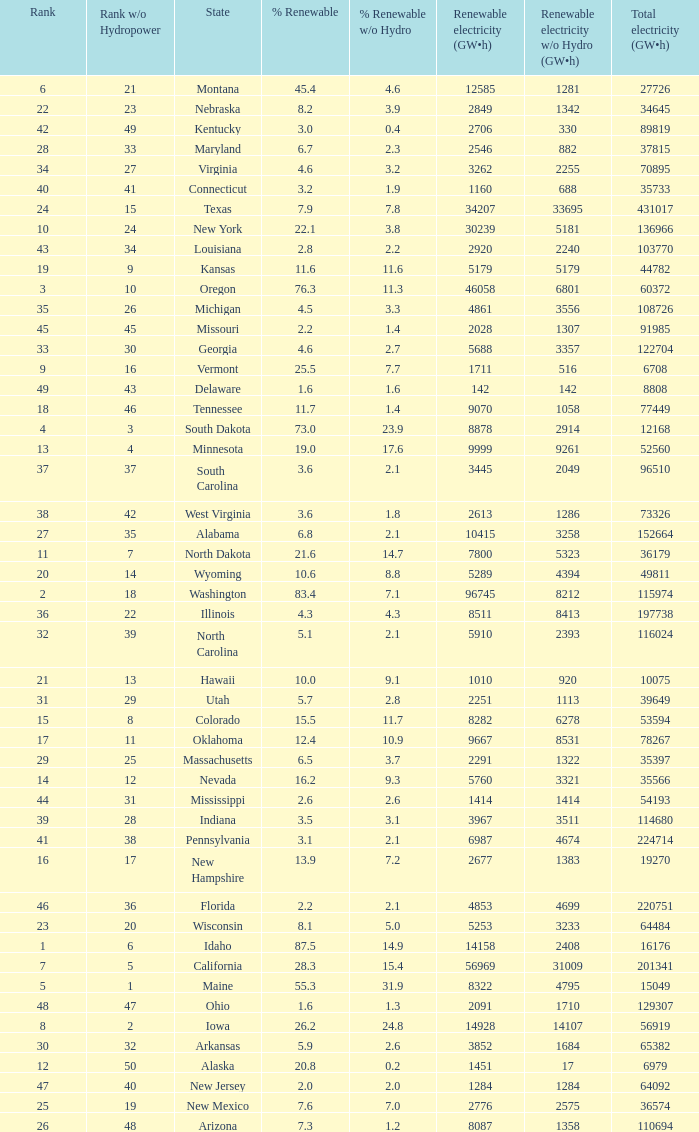What is the amount of renewable electricity without hydrogen power when the percentage of renewable energy is 83.4? 8212.0. 